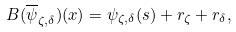<formula> <loc_0><loc_0><loc_500><loc_500>B ( \overline { \psi } _ { \zeta , \delta } ) ( x ) = \psi _ { \zeta , \delta } ( s ) + r _ { \zeta } + r _ { \delta } ,</formula> 